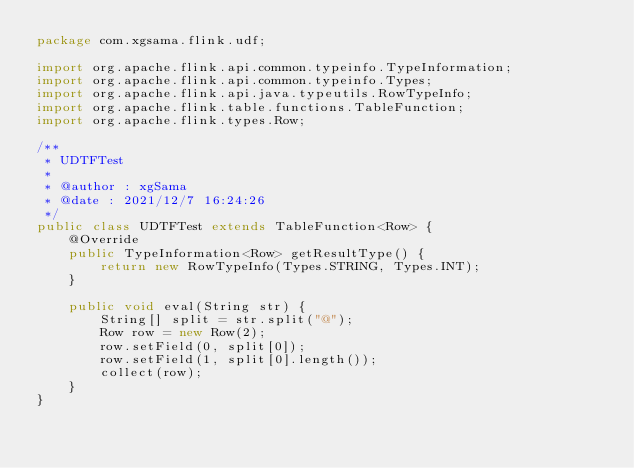Convert code to text. <code><loc_0><loc_0><loc_500><loc_500><_Java_>package com.xgsama.flink.udf;

import org.apache.flink.api.common.typeinfo.TypeInformation;
import org.apache.flink.api.common.typeinfo.Types;
import org.apache.flink.api.java.typeutils.RowTypeInfo;
import org.apache.flink.table.functions.TableFunction;
import org.apache.flink.types.Row;

/**
 * UDTFTest
 *
 * @author : xgSama
 * @date : 2021/12/7 16:24:26
 */
public class UDTFTest extends TableFunction<Row> {
    @Override
    public TypeInformation<Row> getResultType() {
        return new RowTypeInfo(Types.STRING, Types.INT);
    }

    public void eval(String str) {
        String[] split = str.split("@");
        Row row = new Row(2);
        row.setField(0, split[0]);
        row.setField(1, split[0].length());
        collect(row);
    }
}
</code> 